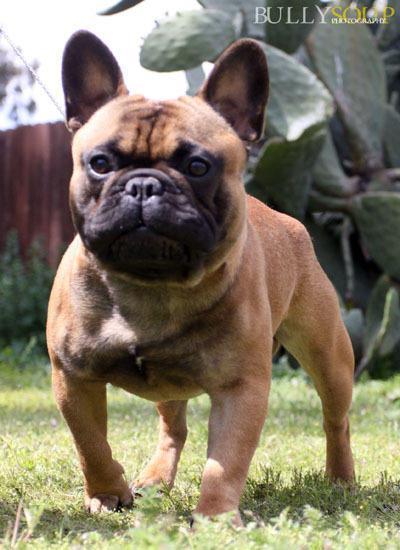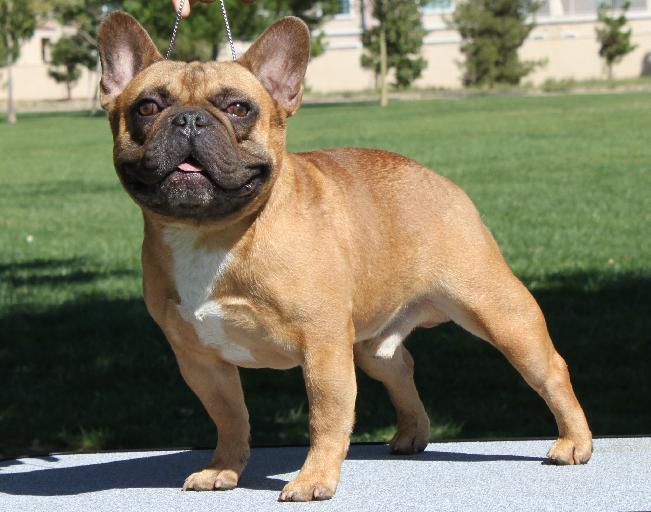The first image is the image on the left, the second image is the image on the right. Assess this claim about the two images: "One of the dogs has their tongue out at least a little bit.". Correct or not? Answer yes or no. Yes. The first image is the image on the left, the second image is the image on the right. Analyze the images presented: Is the assertion "One image shows a charcoal-gray big-eared pup, and one dog in the combined images wears a collar." valid? Answer yes or no. No. 